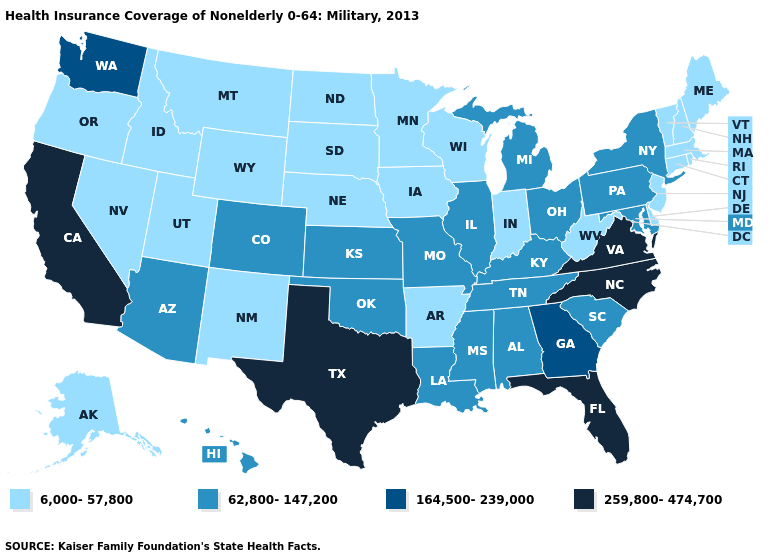What is the value of Kansas?
Give a very brief answer. 62,800-147,200. Name the states that have a value in the range 164,500-239,000?
Short answer required. Georgia, Washington. Which states have the highest value in the USA?
Short answer required. California, Florida, North Carolina, Texas, Virginia. What is the value of South Carolina?
Be succinct. 62,800-147,200. Which states have the highest value in the USA?
Write a very short answer. California, Florida, North Carolina, Texas, Virginia. Does the map have missing data?
Be succinct. No. Which states hav the highest value in the South?
Give a very brief answer. Florida, North Carolina, Texas, Virginia. What is the highest value in the USA?
Keep it brief. 259,800-474,700. Among the states that border Florida , which have the lowest value?
Give a very brief answer. Alabama. Name the states that have a value in the range 164,500-239,000?
Be succinct. Georgia, Washington. Name the states that have a value in the range 164,500-239,000?
Keep it brief. Georgia, Washington. Name the states that have a value in the range 259,800-474,700?
Write a very short answer. California, Florida, North Carolina, Texas, Virginia. What is the value of Connecticut?
Concise answer only. 6,000-57,800. 